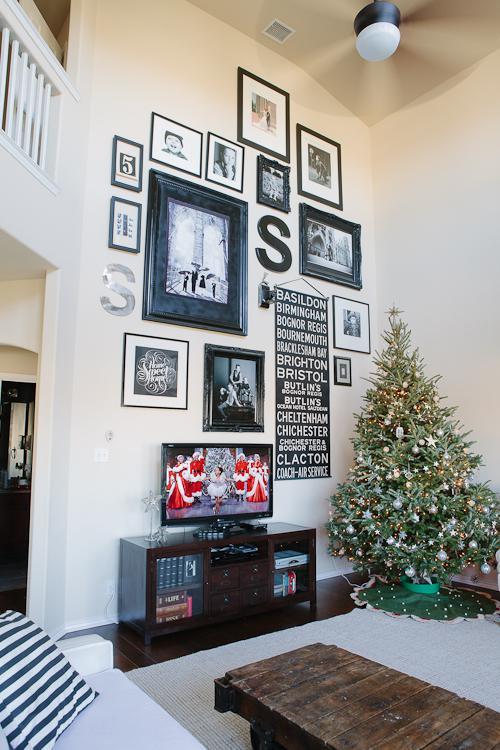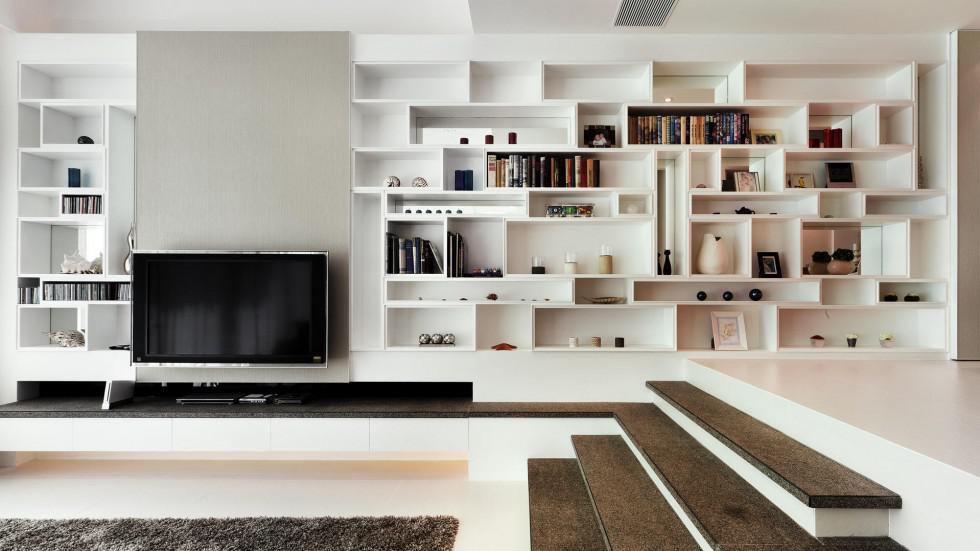The first image is the image on the left, the second image is the image on the right. Considering the images on both sides, is "there is at least one clock on the wall behind the tv" valid? Answer yes or no. No. The first image is the image on the left, the second image is the image on the right. Given the left and right images, does the statement "There is a least one individual letter hanging near a TV." hold true? Answer yes or no. Yes. 